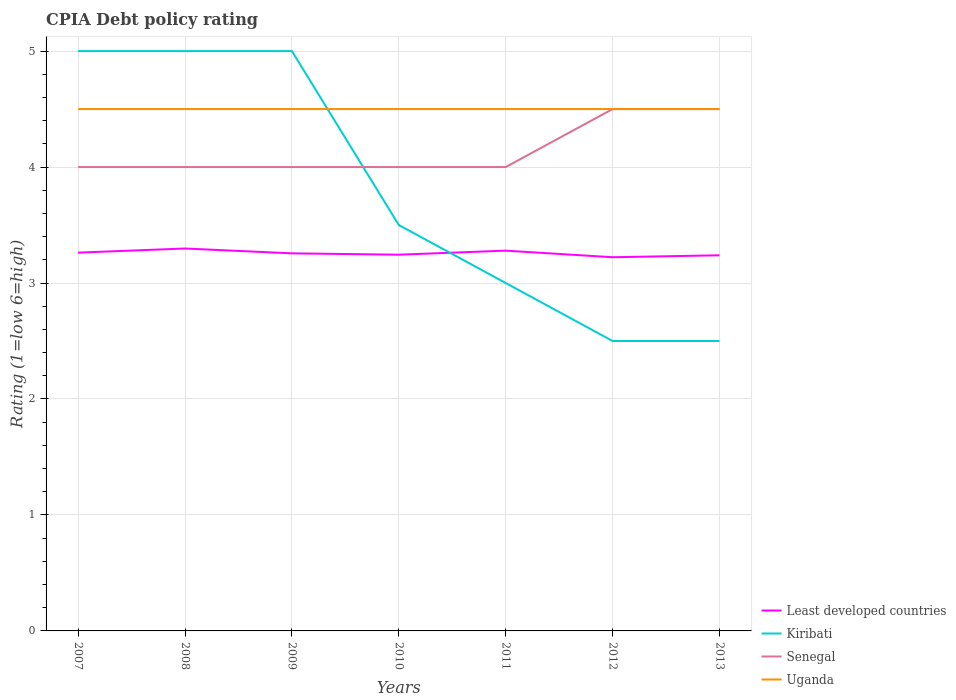How many different coloured lines are there?
Your response must be concise. 4. Does the line corresponding to Kiribati intersect with the line corresponding to Uganda?
Your answer should be very brief. Yes. Is the number of lines equal to the number of legend labels?
Provide a short and direct response. Yes. Across all years, what is the maximum CPIA rating in Least developed countries?
Your answer should be compact. 3.22. In which year was the CPIA rating in Kiribati maximum?
Provide a succinct answer. 2012. What is the total CPIA rating in Least developed countries in the graph?
Your answer should be very brief. -0.02. What is the difference between the highest and the second highest CPIA rating in Uganda?
Provide a short and direct response. 0. What is the difference between the highest and the lowest CPIA rating in Least developed countries?
Make the answer very short. 3. Is the CPIA rating in Kiribati strictly greater than the CPIA rating in Least developed countries over the years?
Ensure brevity in your answer.  No. What is the difference between two consecutive major ticks on the Y-axis?
Offer a terse response. 1. Are the values on the major ticks of Y-axis written in scientific E-notation?
Your response must be concise. No. Does the graph contain any zero values?
Provide a succinct answer. No. How many legend labels are there?
Make the answer very short. 4. How are the legend labels stacked?
Keep it short and to the point. Vertical. What is the title of the graph?
Offer a very short reply. CPIA Debt policy rating. What is the label or title of the Y-axis?
Your response must be concise. Rating (1=low 6=high). What is the Rating (1=low 6=high) in Least developed countries in 2007?
Keep it short and to the point. 3.26. What is the Rating (1=low 6=high) in Kiribati in 2007?
Give a very brief answer. 5. What is the Rating (1=low 6=high) of Senegal in 2007?
Ensure brevity in your answer.  4. What is the Rating (1=low 6=high) in Uganda in 2007?
Your answer should be compact. 4.5. What is the Rating (1=low 6=high) of Least developed countries in 2008?
Give a very brief answer. 3.3. What is the Rating (1=low 6=high) of Senegal in 2008?
Offer a terse response. 4. What is the Rating (1=low 6=high) in Uganda in 2008?
Your response must be concise. 4.5. What is the Rating (1=low 6=high) in Least developed countries in 2009?
Keep it short and to the point. 3.26. What is the Rating (1=low 6=high) of Kiribati in 2009?
Ensure brevity in your answer.  5. What is the Rating (1=low 6=high) of Uganda in 2009?
Give a very brief answer. 4.5. What is the Rating (1=low 6=high) of Least developed countries in 2010?
Offer a very short reply. 3.24. What is the Rating (1=low 6=high) of Kiribati in 2010?
Give a very brief answer. 3.5. What is the Rating (1=low 6=high) of Senegal in 2010?
Make the answer very short. 4. What is the Rating (1=low 6=high) of Uganda in 2010?
Make the answer very short. 4.5. What is the Rating (1=low 6=high) in Least developed countries in 2011?
Offer a very short reply. 3.28. What is the Rating (1=low 6=high) in Kiribati in 2011?
Provide a succinct answer. 3. What is the Rating (1=low 6=high) in Senegal in 2011?
Your response must be concise. 4. What is the Rating (1=low 6=high) in Least developed countries in 2012?
Make the answer very short. 3.22. What is the Rating (1=low 6=high) of Least developed countries in 2013?
Your response must be concise. 3.24. Across all years, what is the maximum Rating (1=low 6=high) in Least developed countries?
Offer a terse response. 3.3. Across all years, what is the maximum Rating (1=low 6=high) of Kiribati?
Your answer should be very brief. 5. Across all years, what is the maximum Rating (1=low 6=high) in Senegal?
Your answer should be very brief. 4.5. Across all years, what is the maximum Rating (1=low 6=high) of Uganda?
Make the answer very short. 4.5. Across all years, what is the minimum Rating (1=low 6=high) of Least developed countries?
Ensure brevity in your answer.  3.22. Across all years, what is the minimum Rating (1=low 6=high) in Kiribati?
Offer a terse response. 2.5. What is the total Rating (1=low 6=high) of Least developed countries in the graph?
Keep it short and to the point. 22.8. What is the total Rating (1=low 6=high) in Kiribati in the graph?
Ensure brevity in your answer.  26.5. What is the total Rating (1=low 6=high) in Uganda in the graph?
Ensure brevity in your answer.  31.5. What is the difference between the Rating (1=low 6=high) in Least developed countries in 2007 and that in 2008?
Provide a short and direct response. -0.04. What is the difference between the Rating (1=low 6=high) in Kiribati in 2007 and that in 2008?
Keep it short and to the point. 0. What is the difference between the Rating (1=low 6=high) in Least developed countries in 2007 and that in 2009?
Provide a short and direct response. 0.01. What is the difference between the Rating (1=low 6=high) in Kiribati in 2007 and that in 2009?
Your answer should be very brief. 0. What is the difference between the Rating (1=low 6=high) of Least developed countries in 2007 and that in 2010?
Ensure brevity in your answer.  0.02. What is the difference between the Rating (1=low 6=high) of Kiribati in 2007 and that in 2010?
Your response must be concise. 1.5. What is the difference between the Rating (1=low 6=high) in Uganda in 2007 and that in 2010?
Offer a very short reply. 0. What is the difference between the Rating (1=low 6=high) in Least developed countries in 2007 and that in 2011?
Make the answer very short. -0.02. What is the difference between the Rating (1=low 6=high) of Uganda in 2007 and that in 2011?
Give a very brief answer. 0. What is the difference between the Rating (1=low 6=high) of Least developed countries in 2007 and that in 2012?
Your answer should be very brief. 0.04. What is the difference between the Rating (1=low 6=high) in Kiribati in 2007 and that in 2012?
Ensure brevity in your answer.  2.5. What is the difference between the Rating (1=low 6=high) of Senegal in 2007 and that in 2012?
Provide a succinct answer. -0.5. What is the difference between the Rating (1=low 6=high) in Uganda in 2007 and that in 2012?
Make the answer very short. 0. What is the difference between the Rating (1=low 6=high) in Least developed countries in 2007 and that in 2013?
Provide a short and direct response. 0.02. What is the difference between the Rating (1=low 6=high) of Senegal in 2007 and that in 2013?
Offer a very short reply. -0.5. What is the difference between the Rating (1=low 6=high) in Least developed countries in 2008 and that in 2009?
Provide a short and direct response. 0.04. What is the difference between the Rating (1=low 6=high) of Kiribati in 2008 and that in 2009?
Make the answer very short. 0. What is the difference between the Rating (1=low 6=high) of Uganda in 2008 and that in 2009?
Ensure brevity in your answer.  0. What is the difference between the Rating (1=low 6=high) in Least developed countries in 2008 and that in 2010?
Your answer should be compact. 0.05. What is the difference between the Rating (1=low 6=high) of Kiribati in 2008 and that in 2010?
Make the answer very short. 1.5. What is the difference between the Rating (1=low 6=high) of Least developed countries in 2008 and that in 2011?
Your answer should be compact. 0.02. What is the difference between the Rating (1=low 6=high) of Senegal in 2008 and that in 2011?
Your answer should be compact. 0. What is the difference between the Rating (1=low 6=high) of Least developed countries in 2008 and that in 2012?
Keep it short and to the point. 0.08. What is the difference between the Rating (1=low 6=high) of Uganda in 2008 and that in 2012?
Ensure brevity in your answer.  0. What is the difference between the Rating (1=low 6=high) of Least developed countries in 2008 and that in 2013?
Ensure brevity in your answer.  0.06. What is the difference between the Rating (1=low 6=high) in Uganda in 2008 and that in 2013?
Offer a terse response. 0. What is the difference between the Rating (1=low 6=high) in Least developed countries in 2009 and that in 2010?
Keep it short and to the point. 0.01. What is the difference between the Rating (1=low 6=high) in Kiribati in 2009 and that in 2010?
Keep it short and to the point. 1.5. What is the difference between the Rating (1=low 6=high) in Senegal in 2009 and that in 2010?
Your answer should be compact. 0. What is the difference between the Rating (1=low 6=high) of Uganda in 2009 and that in 2010?
Keep it short and to the point. 0. What is the difference between the Rating (1=low 6=high) in Least developed countries in 2009 and that in 2011?
Keep it short and to the point. -0.02. What is the difference between the Rating (1=low 6=high) of Senegal in 2009 and that in 2011?
Offer a very short reply. 0. What is the difference between the Rating (1=low 6=high) in Uganda in 2009 and that in 2011?
Your response must be concise. 0. What is the difference between the Rating (1=low 6=high) in Least developed countries in 2009 and that in 2012?
Provide a short and direct response. 0.03. What is the difference between the Rating (1=low 6=high) in Kiribati in 2009 and that in 2012?
Your answer should be very brief. 2.5. What is the difference between the Rating (1=low 6=high) of Senegal in 2009 and that in 2012?
Keep it short and to the point. -0.5. What is the difference between the Rating (1=low 6=high) in Uganda in 2009 and that in 2012?
Make the answer very short. 0. What is the difference between the Rating (1=low 6=high) of Least developed countries in 2009 and that in 2013?
Give a very brief answer. 0.02. What is the difference between the Rating (1=low 6=high) in Uganda in 2009 and that in 2013?
Ensure brevity in your answer.  0. What is the difference between the Rating (1=low 6=high) in Least developed countries in 2010 and that in 2011?
Your response must be concise. -0.03. What is the difference between the Rating (1=low 6=high) in Senegal in 2010 and that in 2011?
Keep it short and to the point. 0. What is the difference between the Rating (1=low 6=high) of Least developed countries in 2010 and that in 2012?
Your response must be concise. 0.02. What is the difference between the Rating (1=low 6=high) of Least developed countries in 2010 and that in 2013?
Make the answer very short. 0.01. What is the difference between the Rating (1=low 6=high) in Kiribati in 2010 and that in 2013?
Provide a succinct answer. 1. What is the difference between the Rating (1=low 6=high) in Uganda in 2010 and that in 2013?
Give a very brief answer. 0. What is the difference between the Rating (1=low 6=high) of Least developed countries in 2011 and that in 2012?
Provide a short and direct response. 0.06. What is the difference between the Rating (1=low 6=high) of Kiribati in 2011 and that in 2012?
Provide a short and direct response. 0.5. What is the difference between the Rating (1=low 6=high) of Senegal in 2011 and that in 2012?
Offer a very short reply. -0.5. What is the difference between the Rating (1=low 6=high) of Least developed countries in 2011 and that in 2013?
Offer a very short reply. 0.04. What is the difference between the Rating (1=low 6=high) of Kiribati in 2011 and that in 2013?
Provide a succinct answer. 0.5. What is the difference between the Rating (1=low 6=high) in Least developed countries in 2012 and that in 2013?
Ensure brevity in your answer.  -0.02. What is the difference between the Rating (1=low 6=high) in Kiribati in 2012 and that in 2013?
Provide a short and direct response. 0. What is the difference between the Rating (1=low 6=high) in Uganda in 2012 and that in 2013?
Keep it short and to the point. 0. What is the difference between the Rating (1=low 6=high) in Least developed countries in 2007 and the Rating (1=low 6=high) in Kiribati in 2008?
Provide a short and direct response. -1.74. What is the difference between the Rating (1=low 6=high) of Least developed countries in 2007 and the Rating (1=low 6=high) of Senegal in 2008?
Your response must be concise. -0.74. What is the difference between the Rating (1=low 6=high) of Least developed countries in 2007 and the Rating (1=low 6=high) of Uganda in 2008?
Make the answer very short. -1.24. What is the difference between the Rating (1=low 6=high) of Kiribati in 2007 and the Rating (1=low 6=high) of Uganda in 2008?
Make the answer very short. 0.5. What is the difference between the Rating (1=low 6=high) of Least developed countries in 2007 and the Rating (1=low 6=high) of Kiribati in 2009?
Provide a short and direct response. -1.74. What is the difference between the Rating (1=low 6=high) of Least developed countries in 2007 and the Rating (1=low 6=high) of Senegal in 2009?
Provide a succinct answer. -0.74. What is the difference between the Rating (1=low 6=high) of Least developed countries in 2007 and the Rating (1=low 6=high) of Uganda in 2009?
Keep it short and to the point. -1.24. What is the difference between the Rating (1=low 6=high) in Least developed countries in 2007 and the Rating (1=low 6=high) in Kiribati in 2010?
Provide a short and direct response. -0.24. What is the difference between the Rating (1=low 6=high) of Least developed countries in 2007 and the Rating (1=low 6=high) of Senegal in 2010?
Your response must be concise. -0.74. What is the difference between the Rating (1=low 6=high) of Least developed countries in 2007 and the Rating (1=low 6=high) of Uganda in 2010?
Provide a short and direct response. -1.24. What is the difference between the Rating (1=low 6=high) of Kiribati in 2007 and the Rating (1=low 6=high) of Senegal in 2010?
Your answer should be compact. 1. What is the difference between the Rating (1=low 6=high) in Least developed countries in 2007 and the Rating (1=low 6=high) in Kiribati in 2011?
Provide a short and direct response. 0.26. What is the difference between the Rating (1=low 6=high) in Least developed countries in 2007 and the Rating (1=low 6=high) in Senegal in 2011?
Offer a terse response. -0.74. What is the difference between the Rating (1=low 6=high) of Least developed countries in 2007 and the Rating (1=low 6=high) of Uganda in 2011?
Provide a short and direct response. -1.24. What is the difference between the Rating (1=low 6=high) of Senegal in 2007 and the Rating (1=low 6=high) of Uganda in 2011?
Offer a terse response. -0.5. What is the difference between the Rating (1=low 6=high) in Least developed countries in 2007 and the Rating (1=low 6=high) in Kiribati in 2012?
Give a very brief answer. 0.76. What is the difference between the Rating (1=low 6=high) of Least developed countries in 2007 and the Rating (1=low 6=high) of Senegal in 2012?
Offer a terse response. -1.24. What is the difference between the Rating (1=low 6=high) in Least developed countries in 2007 and the Rating (1=low 6=high) in Uganda in 2012?
Your answer should be compact. -1.24. What is the difference between the Rating (1=low 6=high) of Kiribati in 2007 and the Rating (1=low 6=high) of Uganda in 2012?
Make the answer very short. 0.5. What is the difference between the Rating (1=low 6=high) in Senegal in 2007 and the Rating (1=low 6=high) in Uganda in 2012?
Keep it short and to the point. -0.5. What is the difference between the Rating (1=low 6=high) in Least developed countries in 2007 and the Rating (1=low 6=high) in Kiribati in 2013?
Ensure brevity in your answer.  0.76. What is the difference between the Rating (1=low 6=high) in Least developed countries in 2007 and the Rating (1=low 6=high) in Senegal in 2013?
Ensure brevity in your answer.  -1.24. What is the difference between the Rating (1=low 6=high) of Least developed countries in 2007 and the Rating (1=low 6=high) of Uganda in 2013?
Ensure brevity in your answer.  -1.24. What is the difference between the Rating (1=low 6=high) of Kiribati in 2007 and the Rating (1=low 6=high) of Senegal in 2013?
Offer a terse response. 0.5. What is the difference between the Rating (1=low 6=high) of Senegal in 2007 and the Rating (1=low 6=high) of Uganda in 2013?
Ensure brevity in your answer.  -0.5. What is the difference between the Rating (1=low 6=high) of Least developed countries in 2008 and the Rating (1=low 6=high) of Kiribati in 2009?
Keep it short and to the point. -1.7. What is the difference between the Rating (1=low 6=high) in Least developed countries in 2008 and the Rating (1=low 6=high) in Senegal in 2009?
Provide a succinct answer. -0.7. What is the difference between the Rating (1=low 6=high) in Least developed countries in 2008 and the Rating (1=low 6=high) in Uganda in 2009?
Keep it short and to the point. -1.2. What is the difference between the Rating (1=low 6=high) in Kiribati in 2008 and the Rating (1=low 6=high) in Uganda in 2009?
Provide a short and direct response. 0.5. What is the difference between the Rating (1=low 6=high) in Least developed countries in 2008 and the Rating (1=low 6=high) in Kiribati in 2010?
Your answer should be very brief. -0.2. What is the difference between the Rating (1=low 6=high) in Least developed countries in 2008 and the Rating (1=low 6=high) in Senegal in 2010?
Provide a succinct answer. -0.7. What is the difference between the Rating (1=low 6=high) of Least developed countries in 2008 and the Rating (1=low 6=high) of Uganda in 2010?
Ensure brevity in your answer.  -1.2. What is the difference between the Rating (1=low 6=high) in Kiribati in 2008 and the Rating (1=low 6=high) in Senegal in 2010?
Offer a terse response. 1. What is the difference between the Rating (1=low 6=high) of Kiribati in 2008 and the Rating (1=low 6=high) of Uganda in 2010?
Provide a succinct answer. 0.5. What is the difference between the Rating (1=low 6=high) of Senegal in 2008 and the Rating (1=low 6=high) of Uganda in 2010?
Make the answer very short. -0.5. What is the difference between the Rating (1=low 6=high) in Least developed countries in 2008 and the Rating (1=low 6=high) in Kiribati in 2011?
Your answer should be very brief. 0.3. What is the difference between the Rating (1=low 6=high) in Least developed countries in 2008 and the Rating (1=low 6=high) in Senegal in 2011?
Your answer should be very brief. -0.7. What is the difference between the Rating (1=low 6=high) in Least developed countries in 2008 and the Rating (1=low 6=high) in Uganda in 2011?
Keep it short and to the point. -1.2. What is the difference between the Rating (1=low 6=high) of Kiribati in 2008 and the Rating (1=low 6=high) of Uganda in 2011?
Your answer should be compact. 0.5. What is the difference between the Rating (1=low 6=high) in Senegal in 2008 and the Rating (1=low 6=high) in Uganda in 2011?
Your answer should be compact. -0.5. What is the difference between the Rating (1=low 6=high) of Least developed countries in 2008 and the Rating (1=low 6=high) of Kiribati in 2012?
Your answer should be very brief. 0.8. What is the difference between the Rating (1=low 6=high) in Least developed countries in 2008 and the Rating (1=low 6=high) in Senegal in 2012?
Make the answer very short. -1.2. What is the difference between the Rating (1=low 6=high) of Least developed countries in 2008 and the Rating (1=low 6=high) of Uganda in 2012?
Make the answer very short. -1.2. What is the difference between the Rating (1=low 6=high) in Kiribati in 2008 and the Rating (1=low 6=high) in Uganda in 2012?
Provide a short and direct response. 0.5. What is the difference between the Rating (1=low 6=high) in Least developed countries in 2008 and the Rating (1=low 6=high) in Kiribati in 2013?
Your answer should be compact. 0.8. What is the difference between the Rating (1=low 6=high) in Least developed countries in 2008 and the Rating (1=low 6=high) in Senegal in 2013?
Make the answer very short. -1.2. What is the difference between the Rating (1=low 6=high) in Least developed countries in 2008 and the Rating (1=low 6=high) in Uganda in 2013?
Keep it short and to the point. -1.2. What is the difference between the Rating (1=low 6=high) in Kiribati in 2008 and the Rating (1=low 6=high) in Senegal in 2013?
Keep it short and to the point. 0.5. What is the difference between the Rating (1=low 6=high) in Kiribati in 2008 and the Rating (1=low 6=high) in Uganda in 2013?
Keep it short and to the point. 0.5. What is the difference between the Rating (1=low 6=high) of Least developed countries in 2009 and the Rating (1=low 6=high) of Kiribati in 2010?
Keep it short and to the point. -0.24. What is the difference between the Rating (1=low 6=high) in Least developed countries in 2009 and the Rating (1=low 6=high) in Senegal in 2010?
Offer a terse response. -0.74. What is the difference between the Rating (1=low 6=high) in Least developed countries in 2009 and the Rating (1=low 6=high) in Uganda in 2010?
Make the answer very short. -1.24. What is the difference between the Rating (1=low 6=high) in Kiribati in 2009 and the Rating (1=low 6=high) in Senegal in 2010?
Provide a succinct answer. 1. What is the difference between the Rating (1=low 6=high) of Senegal in 2009 and the Rating (1=low 6=high) of Uganda in 2010?
Offer a very short reply. -0.5. What is the difference between the Rating (1=low 6=high) in Least developed countries in 2009 and the Rating (1=low 6=high) in Kiribati in 2011?
Ensure brevity in your answer.  0.26. What is the difference between the Rating (1=low 6=high) of Least developed countries in 2009 and the Rating (1=low 6=high) of Senegal in 2011?
Your answer should be very brief. -0.74. What is the difference between the Rating (1=low 6=high) in Least developed countries in 2009 and the Rating (1=low 6=high) in Uganda in 2011?
Your answer should be very brief. -1.24. What is the difference between the Rating (1=low 6=high) of Kiribati in 2009 and the Rating (1=low 6=high) of Senegal in 2011?
Provide a short and direct response. 1. What is the difference between the Rating (1=low 6=high) of Least developed countries in 2009 and the Rating (1=low 6=high) of Kiribati in 2012?
Keep it short and to the point. 0.76. What is the difference between the Rating (1=low 6=high) in Least developed countries in 2009 and the Rating (1=low 6=high) in Senegal in 2012?
Ensure brevity in your answer.  -1.24. What is the difference between the Rating (1=low 6=high) in Least developed countries in 2009 and the Rating (1=low 6=high) in Uganda in 2012?
Give a very brief answer. -1.24. What is the difference between the Rating (1=low 6=high) in Kiribati in 2009 and the Rating (1=low 6=high) in Uganda in 2012?
Give a very brief answer. 0.5. What is the difference between the Rating (1=low 6=high) in Senegal in 2009 and the Rating (1=low 6=high) in Uganda in 2012?
Provide a succinct answer. -0.5. What is the difference between the Rating (1=low 6=high) in Least developed countries in 2009 and the Rating (1=low 6=high) in Kiribati in 2013?
Offer a very short reply. 0.76. What is the difference between the Rating (1=low 6=high) in Least developed countries in 2009 and the Rating (1=low 6=high) in Senegal in 2013?
Your answer should be very brief. -1.24. What is the difference between the Rating (1=low 6=high) of Least developed countries in 2009 and the Rating (1=low 6=high) of Uganda in 2013?
Offer a terse response. -1.24. What is the difference between the Rating (1=low 6=high) of Kiribati in 2009 and the Rating (1=low 6=high) of Senegal in 2013?
Offer a very short reply. 0.5. What is the difference between the Rating (1=low 6=high) of Kiribati in 2009 and the Rating (1=low 6=high) of Uganda in 2013?
Give a very brief answer. 0.5. What is the difference between the Rating (1=low 6=high) in Senegal in 2009 and the Rating (1=low 6=high) in Uganda in 2013?
Make the answer very short. -0.5. What is the difference between the Rating (1=low 6=high) of Least developed countries in 2010 and the Rating (1=low 6=high) of Kiribati in 2011?
Make the answer very short. 0.24. What is the difference between the Rating (1=low 6=high) of Least developed countries in 2010 and the Rating (1=low 6=high) of Senegal in 2011?
Your answer should be compact. -0.76. What is the difference between the Rating (1=low 6=high) of Least developed countries in 2010 and the Rating (1=low 6=high) of Uganda in 2011?
Make the answer very short. -1.26. What is the difference between the Rating (1=low 6=high) in Kiribati in 2010 and the Rating (1=low 6=high) in Uganda in 2011?
Make the answer very short. -1. What is the difference between the Rating (1=low 6=high) of Least developed countries in 2010 and the Rating (1=low 6=high) of Kiribati in 2012?
Make the answer very short. 0.74. What is the difference between the Rating (1=low 6=high) in Least developed countries in 2010 and the Rating (1=low 6=high) in Senegal in 2012?
Offer a very short reply. -1.26. What is the difference between the Rating (1=low 6=high) of Least developed countries in 2010 and the Rating (1=low 6=high) of Uganda in 2012?
Make the answer very short. -1.26. What is the difference between the Rating (1=low 6=high) in Least developed countries in 2010 and the Rating (1=low 6=high) in Kiribati in 2013?
Provide a succinct answer. 0.74. What is the difference between the Rating (1=low 6=high) of Least developed countries in 2010 and the Rating (1=low 6=high) of Senegal in 2013?
Offer a terse response. -1.26. What is the difference between the Rating (1=low 6=high) in Least developed countries in 2010 and the Rating (1=low 6=high) in Uganda in 2013?
Offer a terse response. -1.26. What is the difference between the Rating (1=low 6=high) in Least developed countries in 2011 and the Rating (1=low 6=high) in Kiribati in 2012?
Provide a succinct answer. 0.78. What is the difference between the Rating (1=low 6=high) in Least developed countries in 2011 and the Rating (1=low 6=high) in Senegal in 2012?
Your response must be concise. -1.22. What is the difference between the Rating (1=low 6=high) of Least developed countries in 2011 and the Rating (1=low 6=high) of Uganda in 2012?
Offer a terse response. -1.22. What is the difference between the Rating (1=low 6=high) of Kiribati in 2011 and the Rating (1=low 6=high) of Uganda in 2012?
Give a very brief answer. -1.5. What is the difference between the Rating (1=low 6=high) in Least developed countries in 2011 and the Rating (1=low 6=high) in Kiribati in 2013?
Ensure brevity in your answer.  0.78. What is the difference between the Rating (1=low 6=high) of Least developed countries in 2011 and the Rating (1=low 6=high) of Senegal in 2013?
Ensure brevity in your answer.  -1.22. What is the difference between the Rating (1=low 6=high) in Least developed countries in 2011 and the Rating (1=low 6=high) in Uganda in 2013?
Keep it short and to the point. -1.22. What is the difference between the Rating (1=low 6=high) in Kiribati in 2011 and the Rating (1=low 6=high) in Senegal in 2013?
Make the answer very short. -1.5. What is the difference between the Rating (1=low 6=high) in Senegal in 2011 and the Rating (1=low 6=high) in Uganda in 2013?
Your answer should be very brief. -0.5. What is the difference between the Rating (1=low 6=high) of Least developed countries in 2012 and the Rating (1=low 6=high) of Kiribati in 2013?
Provide a succinct answer. 0.72. What is the difference between the Rating (1=low 6=high) in Least developed countries in 2012 and the Rating (1=low 6=high) in Senegal in 2013?
Make the answer very short. -1.28. What is the difference between the Rating (1=low 6=high) of Least developed countries in 2012 and the Rating (1=low 6=high) of Uganda in 2013?
Offer a terse response. -1.28. What is the difference between the Rating (1=low 6=high) of Kiribati in 2012 and the Rating (1=low 6=high) of Senegal in 2013?
Provide a short and direct response. -2. What is the average Rating (1=low 6=high) in Least developed countries per year?
Ensure brevity in your answer.  3.26. What is the average Rating (1=low 6=high) of Kiribati per year?
Make the answer very short. 3.79. What is the average Rating (1=low 6=high) of Senegal per year?
Your answer should be very brief. 4.14. In the year 2007, what is the difference between the Rating (1=low 6=high) of Least developed countries and Rating (1=low 6=high) of Kiribati?
Make the answer very short. -1.74. In the year 2007, what is the difference between the Rating (1=low 6=high) of Least developed countries and Rating (1=low 6=high) of Senegal?
Your response must be concise. -0.74. In the year 2007, what is the difference between the Rating (1=low 6=high) of Least developed countries and Rating (1=low 6=high) of Uganda?
Keep it short and to the point. -1.24. In the year 2007, what is the difference between the Rating (1=low 6=high) in Kiribati and Rating (1=low 6=high) in Senegal?
Your answer should be very brief. 1. In the year 2007, what is the difference between the Rating (1=low 6=high) of Kiribati and Rating (1=low 6=high) of Uganda?
Offer a very short reply. 0.5. In the year 2007, what is the difference between the Rating (1=low 6=high) of Senegal and Rating (1=low 6=high) of Uganda?
Ensure brevity in your answer.  -0.5. In the year 2008, what is the difference between the Rating (1=low 6=high) of Least developed countries and Rating (1=low 6=high) of Kiribati?
Your answer should be compact. -1.7. In the year 2008, what is the difference between the Rating (1=low 6=high) of Least developed countries and Rating (1=low 6=high) of Senegal?
Offer a very short reply. -0.7. In the year 2008, what is the difference between the Rating (1=low 6=high) in Least developed countries and Rating (1=low 6=high) in Uganda?
Your response must be concise. -1.2. In the year 2008, what is the difference between the Rating (1=low 6=high) of Kiribati and Rating (1=low 6=high) of Senegal?
Make the answer very short. 1. In the year 2009, what is the difference between the Rating (1=low 6=high) in Least developed countries and Rating (1=low 6=high) in Kiribati?
Give a very brief answer. -1.74. In the year 2009, what is the difference between the Rating (1=low 6=high) in Least developed countries and Rating (1=low 6=high) in Senegal?
Give a very brief answer. -0.74. In the year 2009, what is the difference between the Rating (1=low 6=high) in Least developed countries and Rating (1=low 6=high) in Uganda?
Ensure brevity in your answer.  -1.24. In the year 2009, what is the difference between the Rating (1=low 6=high) in Kiribati and Rating (1=low 6=high) in Senegal?
Offer a terse response. 1. In the year 2009, what is the difference between the Rating (1=low 6=high) of Senegal and Rating (1=low 6=high) of Uganda?
Offer a very short reply. -0.5. In the year 2010, what is the difference between the Rating (1=low 6=high) in Least developed countries and Rating (1=low 6=high) in Kiribati?
Make the answer very short. -0.26. In the year 2010, what is the difference between the Rating (1=low 6=high) in Least developed countries and Rating (1=low 6=high) in Senegal?
Your answer should be compact. -0.76. In the year 2010, what is the difference between the Rating (1=low 6=high) in Least developed countries and Rating (1=low 6=high) in Uganda?
Offer a very short reply. -1.26. In the year 2010, what is the difference between the Rating (1=low 6=high) in Kiribati and Rating (1=low 6=high) in Senegal?
Make the answer very short. -0.5. In the year 2010, what is the difference between the Rating (1=low 6=high) of Kiribati and Rating (1=low 6=high) of Uganda?
Your response must be concise. -1. In the year 2011, what is the difference between the Rating (1=low 6=high) in Least developed countries and Rating (1=low 6=high) in Kiribati?
Your response must be concise. 0.28. In the year 2011, what is the difference between the Rating (1=low 6=high) in Least developed countries and Rating (1=low 6=high) in Senegal?
Offer a terse response. -0.72. In the year 2011, what is the difference between the Rating (1=low 6=high) of Least developed countries and Rating (1=low 6=high) of Uganda?
Ensure brevity in your answer.  -1.22. In the year 2011, what is the difference between the Rating (1=low 6=high) of Kiribati and Rating (1=low 6=high) of Senegal?
Your answer should be compact. -1. In the year 2011, what is the difference between the Rating (1=low 6=high) in Kiribati and Rating (1=low 6=high) in Uganda?
Make the answer very short. -1.5. In the year 2012, what is the difference between the Rating (1=low 6=high) of Least developed countries and Rating (1=low 6=high) of Kiribati?
Give a very brief answer. 0.72. In the year 2012, what is the difference between the Rating (1=low 6=high) of Least developed countries and Rating (1=low 6=high) of Senegal?
Provide a short and direct response. -1.28. In the year 2012, what is the difference between the Rating (1=low 6=high) in Least developed countries and Rating (1=low 6=high) in Uganda?
Your answer should be very brief. -1.28. In the year 2012, what is the difference between the Rating (1=low 6=high) of Kiribati and Rating (1=low 6=high) of Uganda?
Offer a terse response. -2. In the year 2013, what is the difference between the Rating (1=low 6=high) in Least developed countries and Rating (1=low 6=high) in Kiribati?
Offer a very short reply. 0.74. In the year 2013, what is the difference between the Rating (1=low 6=high) of Least developed countries and Rating (1=low 6=high) of Senegal?
Your response must be concise. -1.26. In the year 2013, what is the difference between the Rating (1=low 6=high) of Least developed countries and Rating (1=low 6=high) of Uganda?
Keep it short and to the point. -1.26. In the year 2013, what is the difference between the Rating (1=low 6=high) of Kiribati and Rating (1=low 6=high) of Uganda?
Ensure brevity in your answer.  -2. In the year 2013, what is the difference between the Rating (1=low 6=high) of Senegal and Rating (1=low 6=high) of Uganda?
Your answer should be very brief. 0. What is the ratio of the Rating (1=low 6=high) of Uganda in 2007 to that in 2008?
Make the answer very short. 1. What is the ratio of the Rating (1=low 6=high) of Senegal in 2007 to that in 2009?
Your answer should be very brief. 1. What is the ratio of the Rating (1=low 6=high) in Kiribati in 2007 to that in 2010?
Provide a short and direct response. 1.43. What is the ratio of the Rating (1=low 6=high) in Senegal in 2007 to that in 2010?
Your answer should be compact. 1. What is the ratio of the Rating (1=low 6=high) in Uganda in 2007 to that in 2010?
Ensure brevity in your answer.  1. What is the ratio of the Rating (1=low 6=high) in Kiribati in 2007 to that in 2011?
Provide a short and direct response. 1.67. What is the ratio of the Rating (1=low 6=high) in Senegal in 2007 to that in 2011?
Provide a short and direct response. 1. What is the ratio of the Rating (1=low 6=high) in Uganda in 2007 to that in 2011?
Make the answer very short. 1. What is the ratio of the Rating (1=low 6=high) of Least developed countries in 2007 to that in 2012?
Provide a succinct answer. 1.01. What is the ratio of the Rating (1=low 6=high) in Senegal in 2007 to that in 2012?
Keep it short and to the point. 0.89. What is the ratio of the Rating (1=low 6=high) of Uganda in 2007 to that in 2012?
Ensure brevity in your answer.  1. What is the ratio of the Rating (1=low 6=high) of Senegal in 2007 to that in 2013?
Offer a terse response. 0.89. What is the ratio of the Rating (1=low 6=high) in Uganda in 2007 to that in 2013?
Give a very brief answer. 1. What is the ratio of the Rating (1=low 6=high) of Least developed countries in 2008 to that in 2009?
Offer a terse response. 1.01. What is the ratio of the Rating (1=low 6=high) in Kiribati in 2008 to that in 2009?
Your answer should be very brief. 1. What is the ratio of the Rating (1=low 6=high) in Senegal in 2008 to that in 2009?
Give a very brief answer. 1. What is the ratio of the Rating (1=low 6=high) of Least developed countries in 2008 to that in 2010?
Your answer should be very brief. 1.02. What is the ratio of the Rating (1=low 6=high) in Kiribati in 2008 to that in 2010?
Provide a succinct answer. 1.43. What is the ratio of the Rating (1=low 6=high) of Least developed countries in 2008 to that in 2011?
Your answer should be very brief. 1.01. What is the ratio of the Rating (1=low 6=high) in Kiribati in 2008 to that in 2011?
Make the answer very short. 1.67. What is the ratio of the Rating (1=low 6=high) of Least developed countries in 2008 to that in 2012?
Your response must be concise. 1.02. What is the ratio of the Rating (1=low 6=high) of Least developed countries in 2008 to that in 2013?
Offer a terse response. 1.02. What is the ratio of the Rating (1=low 6=high) in Senegal in 2008 to that in 2013?
Your response must be concise. 0.89. What is the ratio of the Rating (1=low 6=high) in Uganda in 2008 to that in 2013?
Your response must be concise. 1. What is the ratio of the Rating (1=low 6=high) of Kiribati in 2009 to that in 2010?
Make the answer very short. 1.43. What is the ratio of the Rating (1=low 6=high) of Least developed countries in 2009 to that in 2011?
Your answer should be very brief. 0.99. What is the ratio of the Rating (1=low 6=high) of Kiribati in 2009 to that in 2011?
Your answer should be very brief. 1.67. What is the ratio of the Rating (1=low 6=high) in Senegal in 2009 to that in 2011?
Your answer should be very brief. 1. What is the ratio of the Rating (1=low 6=high) of Least developed countries in 2009 to that in 2012?
Your response must be concise. 1.01. What is the ratio of the Rating (1=low 6=high) in Senegal in 2009 to that in 2012?
Ensure brevity in your answer.  0.89. What is the ratio of the Rating (1=low 6=high) in Kiribati in 2009 to that in 2013?
Your response must be concise. 2. What is the ratio of the Rating (1=low 6=high) of Kiribati in 2010 to that in 2011?
Give a very brief answer. 1.17. What is the ratio of the Rating (1=low 6=high) of Senegal in 2010 to that in 2011?
Offer a very short reply. 1. What is the ratio of the Rating (1=low 6=high) of Least developed countries in 2010 to that in 2012?
Give a very brief answer. 1.01. What is the ratio of the Rating (1=low 6=high) of Kiribati in 2010 to that in 2012?
Offer a terse response. 1.4. What is the ratio of the Rating (1=low 6=high) of Senegal in 2010 to that in 2012?
Provide a short and direct response. 0.89. What is the ratio of the Rating (1=low 6=high) of Least developed countries in 2010 to that in 2013?
Offer a very short reply. 1. What is the ratio of the Rating (1=low 6=high) in Kiribati in 2010 to that in 2013?
Your response must be concise. 1.4. What is the ratio of the Rating (1=low 6=high) in Senegal in 2010 to that in 2013?
Provide a short and direct response. 0.89. What is the ratio of the Rating (1=low 6=high) of Uganda in 2010 to that in 2013?
Offer a very short reply. 1. What is the ratio of the Rating (1=low 6=high) in Least developed countries in 2011 to that in 2012?
Keep it short and to the point. 1.02. What is the ratio of the Rating (1=low 6=high) in Kiribati in 2011 to that in 2012?
Give a very brief answer. 1.2. What is the ratio of the Rating (1=low 6=high) in Least developed countries in 2011 to that in 2013?
Your answer should be very brief. 1.01. What is the ratio of the Rating (1=low 6=high) in Senegal in 2011 to that in 2013?
Keep it short and to the point. 0.89. What is the ratio of the Rating (1=low 6=high) in Uganda in 2011 to that in 2013?
Provide a succinct answer. 1. What is the ratio of the Rating (1=low 6=high) in Least developed countries in 2012 to that in 2013?
Your response must be concise. 0.99. What is the ratio of the Rating (1=low 6=high) in Kiribati in 2012 to that in 2013?
Your response must be concise. 1. What is the difference between the highest and the second highest Rating (1=low 6=high) of Least developed countries?
Your response must be concise. 0.02. What is the difference between the highest and the second highest Rating (1=low 6=high) in Kiribati?
Offer a very short reply. 0. What is the difference between the highest and the lowest Rating (1=low 6=high) in Least developed countries?
Ensure brevity in your answer.  0.08. What is the difference between the highest and the lowest Rating (1=low 6=high) of Senegal?
Give a very brief answer. 0.5. What is the difference between the highest and the lowest Rating (1=low 6=high) of Uganda?
Provide a short and direct response. 0. 